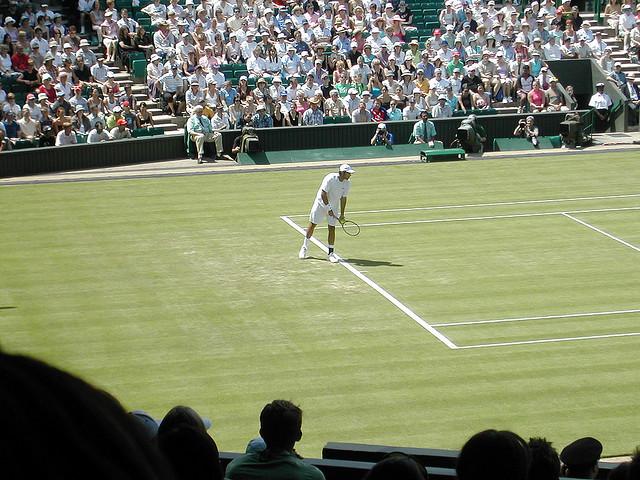What color is the court?
Give a very brief answer. Green. What is the dominant color people are wearing in the crowd?
Write a very short answer. White. What sport are the people watching?
Write a very short answer. Tennis. What color is he wearing?
Answer briefly. White. 